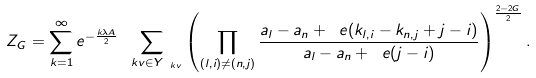<formula> <loc_0><loc_0><loc_500><loc_500>Z _ { G } = \sum _ { k = 1 } ^ { \infty } e ^ { - \frac { k \lambda A } { 2 } } \sum _ { \ k v \in Y _ { \ k v } } \left ( \prod _ { ( l , i ) \neq ( n , j ) } \frac { a _ { l } - a _ { n } + \ e ( k _ { l , i } - k _ { n , j } + j - i ) } { a _ { l } - a _ { n } + \ e ( j - i ) } \right ) ^ { \frac { 2 - 2 G } { 2 } } .</formula> 